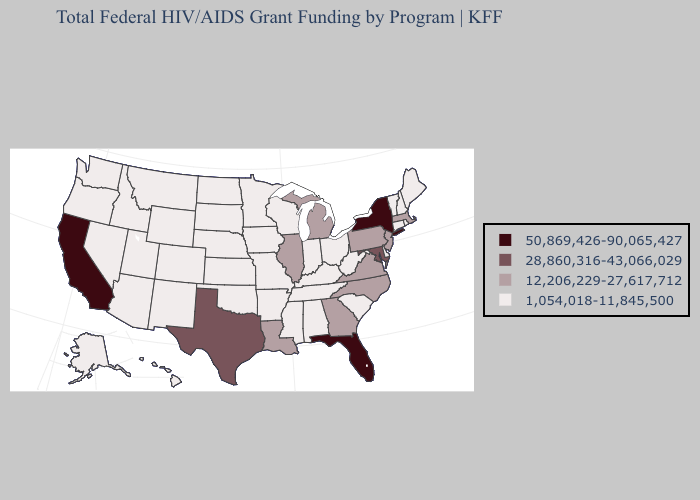What is the value of Rhode Island?
Keep it brief. 1,054,018-11,845,500. Does New York have the highest value in the Northeast?
Give a very brief answer. Yes. Does Wyoming have the lowest value in the West?
Concise answer only. Yes. Name the states that have a value in the range 28,860,316-43,066,029?
Quick response, please. Maryland, Texas. What is the lowest value in the South?
Concise answer only. 1,054,018-11,845,500. Does Louisiana have the lowest value in the USA?
Answer briefly. No. Name the states that have a value in the range 1,054,018-11,845,500?
Answer briefly. Alabama, Alaska, Arizona, Arkansas, Colorado, Connecticut, Delaware, Hawaii, Idaho, Indiana, Iowa, Kansas, Kentucky, Maine, Minnesota, Mississippi, Missouri, Montana, Nebraska, Nevada, New Hampshire, New Mexico, North Dakota, Ohio, Oklahoma, Oregon, Rhode Island, South Carolina, South Dakota, Tennessee, Utah, Vermont, Washington, West Virginia, Wisconsin, Wyoming. How many symbols are there in the legend?
Write a very short answer. 4. What is the value of South Dakota?
Be succinct. 1,054,018-11,845,500. What is the value of Colorado?
Quick response, please. 1,054,018-11,845,500. Among the states that border Wisconsin , which have the lowest value?
Give a very brief answer. Iowa, Minnesota. Name the states that have a value in the range 50,869,426-90,065,427?
Short answer required. California, Florida, New York. Which states hav the highest value in the Northeast?
Give a very brief answer. New York. Among the states that border Indiana , does Michigan have the lowest value?
Answer briefly. No. Name the states that have a value in the range 1,054,018-11,845,500?
Write a very short answer. Alabama, Alaska, Arizona, Arkansas, Colorado, Connecticut, Delaware, Hawaii, Idaho, Indiana, Iowa, Kansas, Kentucky, Maine, Minnesota, Mississippi, Missouri, Montana, Nebraska, Nevada, New Hampshire, New Mexico, North Dakota, Ohio, Oklahoma, Oregon, Rhode Island, South Carolina, South Dakota, Tennessee, Utah, Vermont, Washington, West Virginia, Wisconsin, Wyoming. 